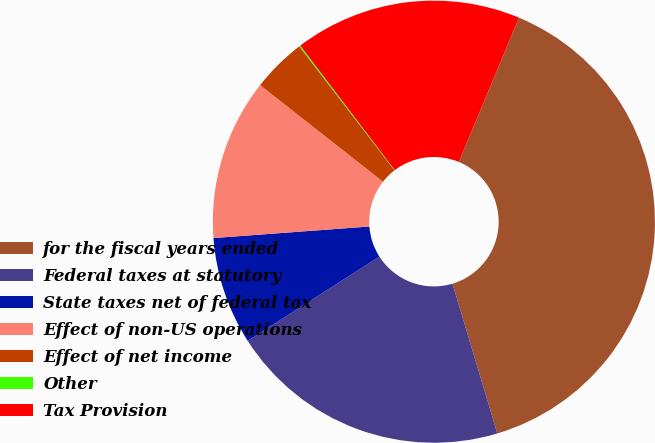Convert chart. <chart><loc_0><loc_0><loc_500><loc_500><pie_chart><fcel>for the fiscal years ended<fcel>Federal taxes at statutory<fcel>State taxes net of federal tax<fcel>Effect of non-US operations<fcel>Effect of net income<fcel>Other<fcel>Tax Provision<nl><fcel>39.08%<fcel>20.57%<fcel>7.88%<fcel>11.78%<fcel>3.98%<fcel>0.09%<fcel>16.62%<nl></chart> 